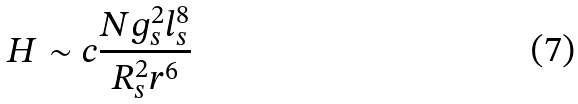Convert formula to latex. <formula><loc_0><loc_0><loc_500><loc_500>H \sim c \frac { N g _ { s } ^ { 2 } l _ { s } ^ { 8 } } { R _ { s } ^ { 2 } r ^ { 6 } }</formula> 